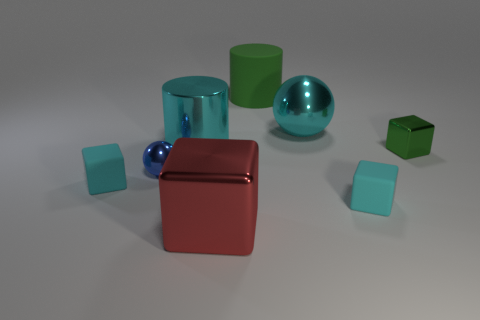How many objects are large metallic cylinders or tiny blue spheres in front of the large green rubber cylinder?
Offer a terse response. 2. What color is the small object to the right of the cyan matte thing in front of the small cyan cube to the left of the blue shiny ball?
Your response must be concise. Green. What is the size of the cyan cube that is right of the large shiny cube?
Offer a very short reply. Small. What number of tiny things are blocks or green shiny cubes?
Provide a succinct answer. 3. The small thing that is right of the big green matte cylinder and in front of the green block is what color?
Offer a very short reply. Cyan. Is there a large yellow rubber object that has the same shape as the small blue metallic thing?
Provide a succinct answer. No. What is the large cyan sphere made of?
Ensure brevity in your answer.  Metal. There is a blue sphere; are there any big metallic cubes on the left side of it?
Your answer should be very brief. No. Does the big red thing have the same shape as the blue object?
Offer a very short reply. No. What number of other objects are the same size as the red object?
Make the answer very short. 3. 